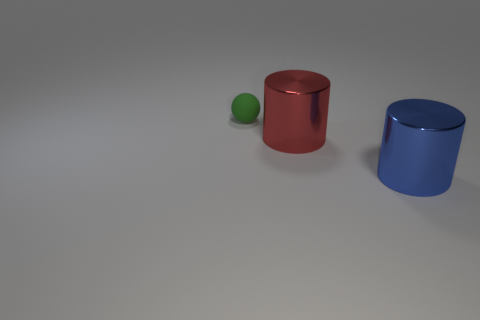What number of metal things are tiny gray blocks or big objects?
Your response must be concise. 2. There is a small green sphere that is on the left side of the big thing on the left side of the big blue shiny thing; what is its material?
Offer a terse response. Rubber. What shape is the other thing that is the same size as the blue thing?
Keep it short and to the point. Cylinder. Is the number of tiny matte spheres less than the number of big red cubes?
Ensure brevity in your answer.  No. There is a shiny object that is in front of the large red metal object; is there a large blue cylinder left of it?
Offer a terse response. No. There is another big object that is made of the same material as the large blue object; what shape is it?
Keep it short and to the point. Cylinder. Are there any other things that have the same color as the rubber ball?
Offer a very short reply. No. There is another big thing that is the same shape as the red metal object; what is its material?
Make the answer very short. Metal. How many other objects are there of the same size as the blue cylinder?
Make the answer very short. 1. Is the shape of the object in front of the red metallic object the same as  the red metal thing?
Offer a terse response. Yes. 